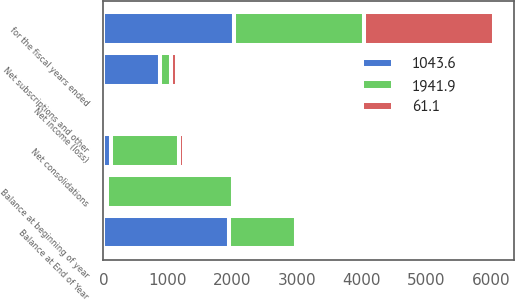<chart> <loc_0><loc_0><loc_500><loc_500><stacked_bar_chart><ecel><fcel>for the fiscal years ended<fcel>Balance at beginning of year<fcel>Net income (loss)<fcel>Net subscriptions and other<fcel>Net consolidations<fcel>Balance at End of Year<nl><fcel>1941.9<fcel>2018<fcel>1941.9<fcel>12.8<fcel>170.9<fcel>1056.4<fcel>1043.6<nl><fcel>1043.6<fcel>2017<fcel>61.1<fcel>53<fcel>884.3<fcel>118.8<fcel>1941.9<nl><fcel>61.1<fcel>2016<fcel>59.6<fcel>1.6<fcel>79.9<fcel>80<fcel>61.1<nl></chart> 